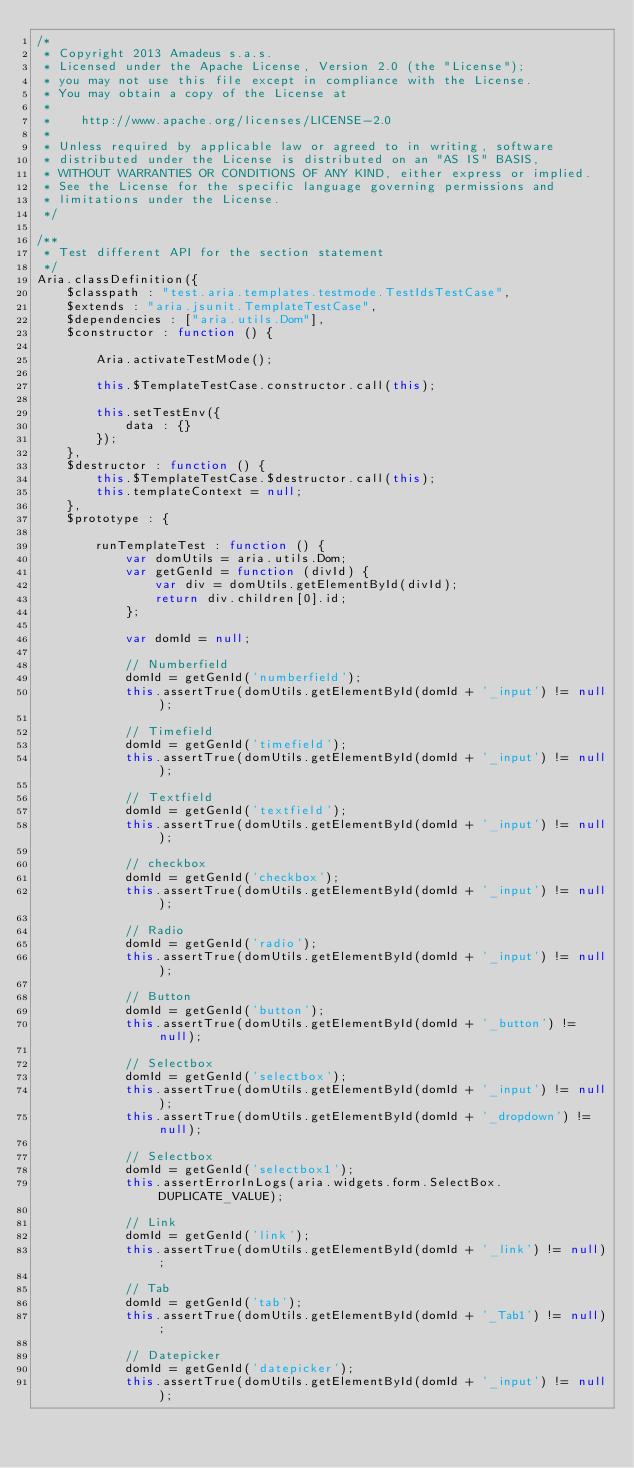Convert code to text. <code><loc_0><loc_0><loc_500><loc_500><_JavaScript_>/*
 * Copyright 2013 Amadeus s.a.s.
 * Licensed under the Apache License, Version 2.0 (the "License");
 * you may not use this file except in compliance with the License.
 * You may obtain a copy of the License at
 *
 *    http://www.apache.org/licenses/LICENSE-2.0
 *
 * Unless required by applicable law or agreed to in writing, software
 * distributed under the License is distributed on an "AS IS" BASIS,
 * WITHOUT WARRANTIES OR CONDITIONS OF ANY KIND, either express or implied.
 * See the License for the specific language governing permissions and
 * limitations under the License.
 */

/**
 * Test different API for the section statement
 */
Aria.classDefinition({
    $classpath : "test.aria.templates.testmode.TestIdsTestCase",
    $extends : "aria.jsunit.TemplateTestCase",
    $dependencies : ["aria.utils.Dom"],
    $constructor : function () {

        Aria.activateTestMode();

        this.$TemplateTestCase.constructor.call(this);

        this.setTestEnv({
            data : {}
        });
    },
    $destructor : function () {
        this.$TemplateTestCase.$destructor.call(this);
        this.templateContext = null;
    },
    $prototype : {

        runTemplateTest : function () {
            var domUtils = aria.utils.Dom;
            var getGenId = function (divId) {
                var div = domUtils.getElementById(divId);
                return div.children[0].id;
            };

            var domId = null;

            // Numberfield
            domId = getGenId('numberfield');
            this.assertTrue(domUtils.getElementById(domId + '_input') != null);

            // Timefield
            domId = getGenId('timefield');
            this.assertTrue(domUtils.getElementById(domId + '_input') != null);

            // Textfield
            domId = getGenId('textfield');
            this.assertTrue(domUtils.getElementById(domId + '_input') != null);

            // checkbox
            domId = getGenId('checkbox');
            this.assertTrue(domUtils.getElementById(domId + '_input') != null);

            // Radio
            domId = getGenId('radio');
            this.assertTrue(domUtils.getElementById(domId + '_input') != null);

            // Button
            domId = getGenId('button');
            this.assertTrue(domUtils.getElementById(domId + '_button') != null);

            // Selectbox
            domId = getGenId('selectbox');
            this.assertTrue(domUtils.getElementById(domId + '_input') != null);
            this.assertTrue(domUtils.getElementById(domId + '_dropdown') != null);

            // Selectbox
            domId = getGenId('selectbox1');
            this.assertErrorInLogs(aria.widgets.form.SelectBox.DUPLICATE_VALUE);

            // Link
            domId = getGenId('link');
            this.assertTrue(domUtils.getElementById(domId + '_link') != null);

            // Tab
            domId = getGenId('tab');
            this.assertTrue(domUtils.getElementById(domId + '_Tab1') != null);

            // Datepicker
            domId = getGenId('datepicker');
            this.assertTrue(domUtils.getElementById(domId + '_input') != null);</code> 